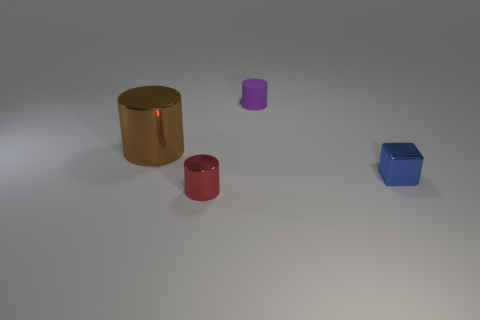Are there any large brown metal things that are right of the tiny cylinder behind the tiny shiny thing right of the tiny purple object?
Ensure brevity in your answer.  No. There is a tiny metallic thing that is behind the red object; is its shape the same as the brown object?
Give a very brief answer. No. Are there fewer brown metallic objects in front of the large metal thing than metallic cylinders to the right of the tiny blue thing?
Offer a very short reply. No. What material is the big cylinder?
Keep it short and to the point. Metal. There is a small matte object; is its color the same as the small cylinder that is in front of the small blue thing?
Keep it short and to the point. No. How many large brown metallic cylinders are to the left of the small blue thing?
Make the answer very short. 1. Is the number of small red metallic cylinders behind the matte cylinder less than the number of green cylinders?
Keep it short and to the point. No. The matte thing has what color?
Give a very brief answer. Purple. Does the metal thing that is to the left of the small red cylinder have the same color as the tiny shiny cylinder?
Offer a very short reply. No. What color is the other matte thing that is the same shape as the large object?
Provide a succinct answer. Purple. 